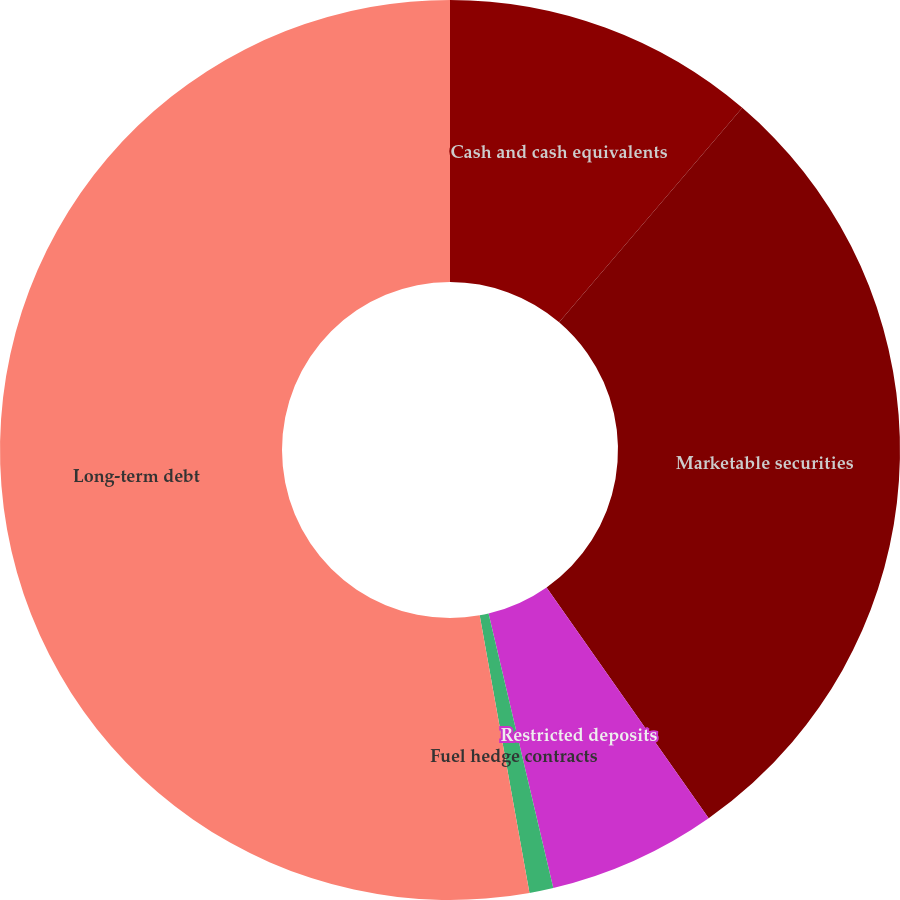<chart> <loc_0><loc_0><loc_500><loc_500><pie_chart><fcel>Cash and cash equivalents<fcel>Marketable securities<fcel>Restricted deposits<fcel>Fuel hedge contracts<fcel>Long-term debt<nl><fcel>11.25%<fcel>29.0%<fcel>6.06%<fcel>0.86%<fcel>52.82%<nl></chart> 